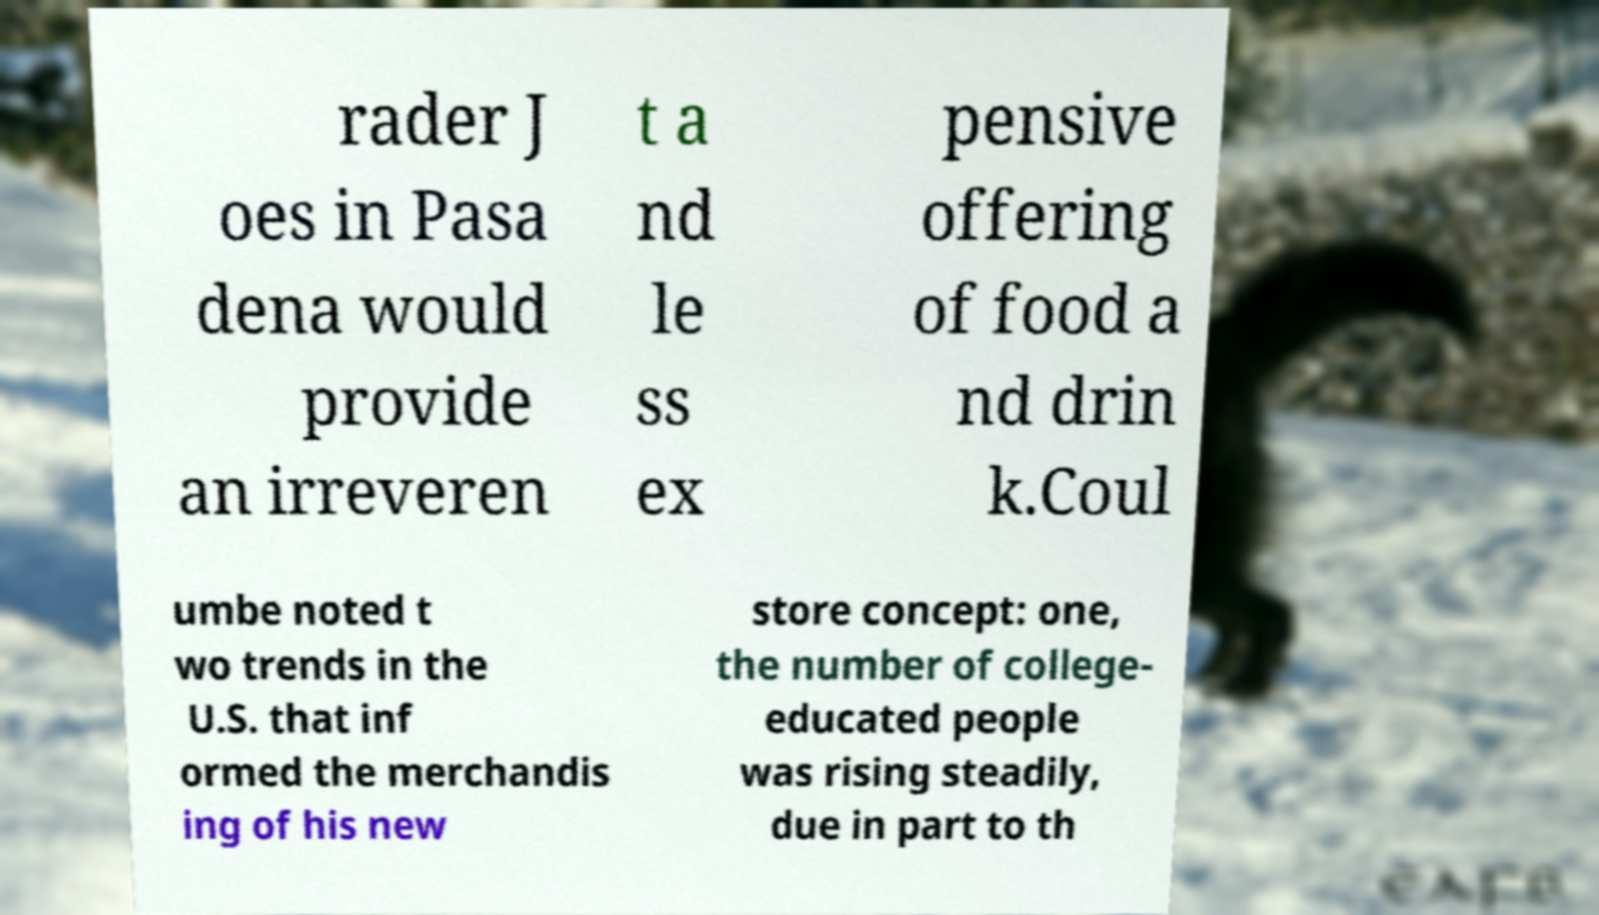Could you extract and type out the text from this image? rader J oes in Pasa dena would provide an irreveren t a nd le ss ex pensive offering of food a nd drin k.Coul umbe noted t wo trends in the U.S. that inf ormed the merchandis ing of his new store concept: one, the number of college- educated people was rising steadily, due in part to th 